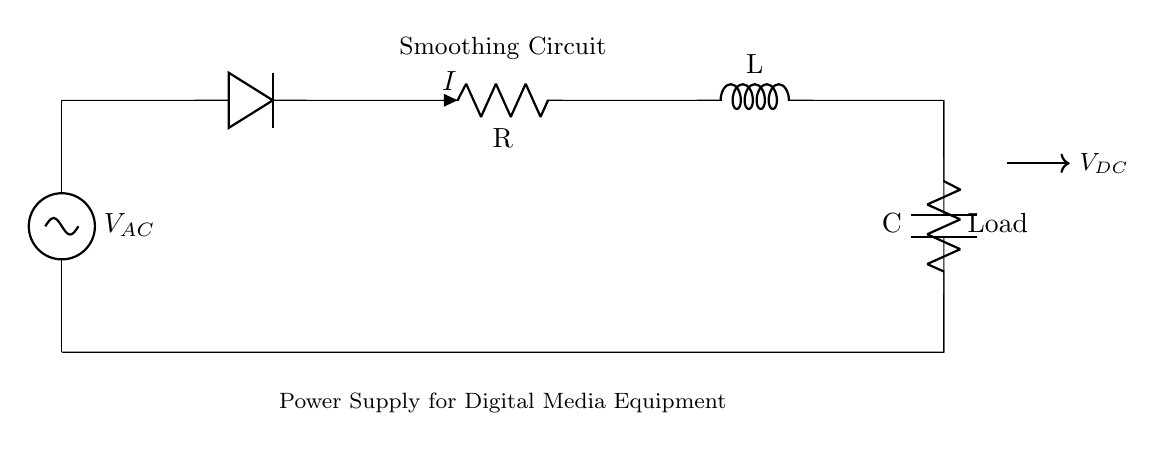What is the type of the voltage source in the circuit? The circuit has an AC voltage source labeled as V_AC, which is indicated at the top-left corner of the diagram.
Answer: AC What components are used in this smoothing circuit? The circuit contains a diode, a resistor, an inductor, a capacitor, and a load resistor, as identified in the diagram.
Answer: Diode, resistor, inductor, capacitor, load What is the purpose of the inductor in this context? The inductor is used to smooth out fluctuations in current flowing from the power supply, thereby filtering the output voltage.
Answer: Smoothing What is the voltage at the output labeled as V_DC? V_DC is the direct current voltage output from the smoothing circuit, but its value is not specified in the diagram; it's the result of rectification and smoothing.
Answer: Not specified Why is a diode included in the circuit? The diode is used to allow current to flow in one direction only, thus converting the alternating current (AC) from the power source into direct current (DC) for the circuit.
Answer: Rectification What role does the capacitor play in the circuit? The capacitor stores electrical energy and releases it to smooth the output voltage, reducing ripple and providing a more stable DC supply.
Answer: Smoothing How do the resistor and inductor together create a power supply smoothing effect? The resistor limits current and dissipates energy, while the inductor stores energy in a magnetic field during periods of high current and releases it when current decreases, resulting in a smoother output.
Answer: Smoothing effect 